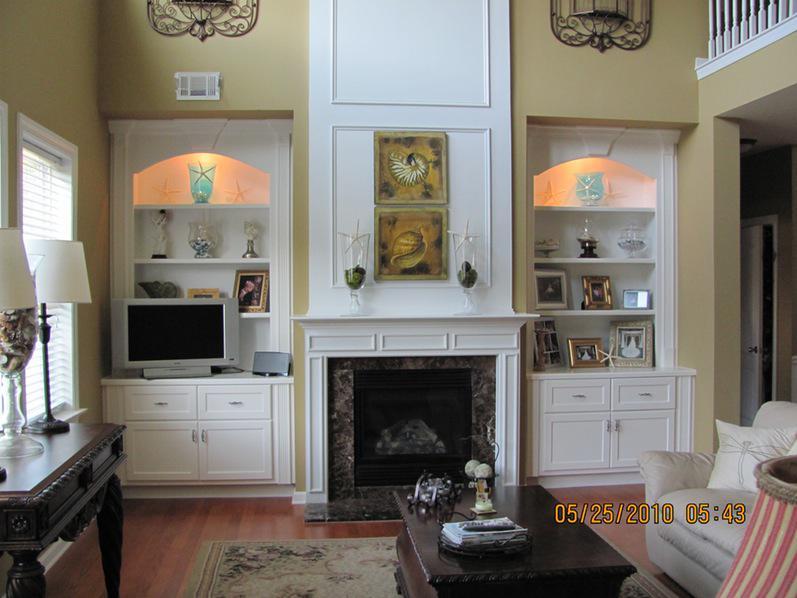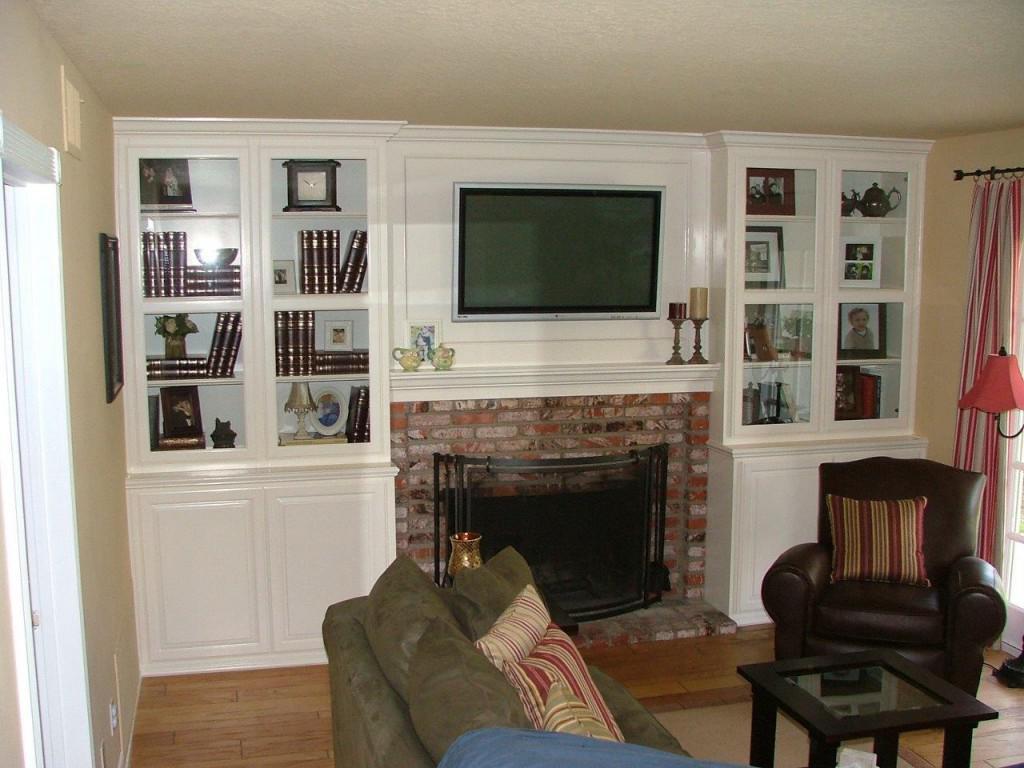The first image is the image on the left, the second image is the image on the right. Analyze the images presented: Is the assertion "One image shows white bookcases with arch shapes above the top shelves, flanking a fireplace that does not have a television mounted above it." valid? Answer yes or no. Yes. The first image is the image on the left, the second image is the image on the right. Evaluate the accuracy of this statement regarding the images: "There are two chair with cream and blue pillows that match the the line painting on the mantle.". Is it true? Answer yes or no. No. 